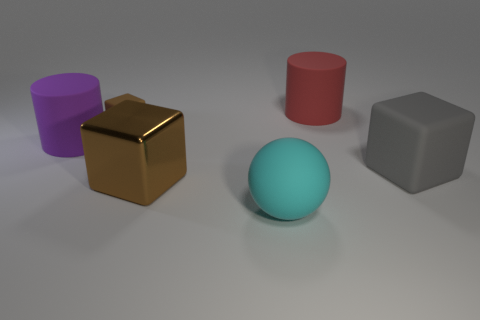Are there any other things that have the same size as the brown rubber object?
Your response must be concise. No. Do the gray object and the small brown cube have the same material?
Provide a succinct answer. Yes. How many spheres are cyan objects or brown objects?
Offer a terse response. 1. How big is the rubber block behind the rubber cube in front of the large cylinder left of the big cyan thing?
Provide a short and direct response. Small. The brown metallic object that is the same shape as the tiny brown rubber object is what size?
Keep it short and to the point. Large. How many large cylinders are in front of the cyan rubber sphere?
Give a very brief answer. 0. Does the cylinder to the right of the large cyan rubber ball have the same color as the small matte object?
Give a very brief answer. No. What number of cyan things are either small blocks or rubber things?
Your answer should be compact. 1. There is a large cylinder on the right side of the large cylinder that is on the left side of the cyan matte thing; what color is it?
Your answer should be compact. Red. There is a tiny thing that is the same color as the large shiny cube; what is it made of?
Your answer should be very brief. Rubber. 